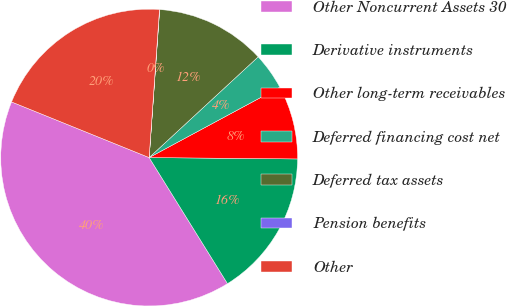Convert chart to OTSL. <chart><loc_0><loc_0><loc_500><loc_500><pie_chart><fcel>Other Noncurrent Assets 30<fcel>Derivative instruments<fcel>Other long-term receivables<fcel>Deferred financing cost net<fcel>Deferred tax assets<fcel>Pension benefits<fcel>Other<nl><fcel>39.97%<fcel>16.0%<fcel>8.01%<fcel>4.01%<fcel>12.0%<fcel>0.02%<fcel>19.99%<nl></chart> 